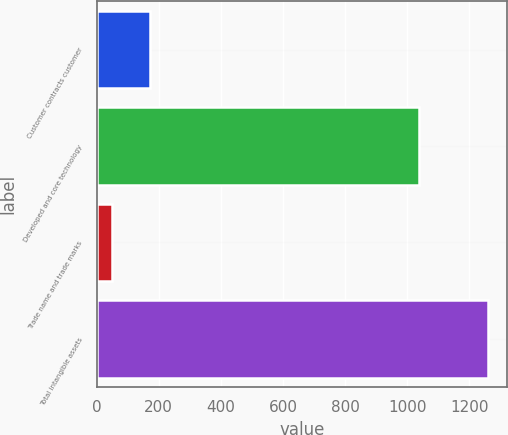<chart> <loc_0><loc_0><loc_500><loc_500><bar_chart><fcel>Customer contracts customer<fcel>Developed and core technology<fcel>Trade name and trade marks<fcel>Total intangible assets<nl><fcel>173<fcel>1037<fcel>49<fcel>1259<nl></chart> 